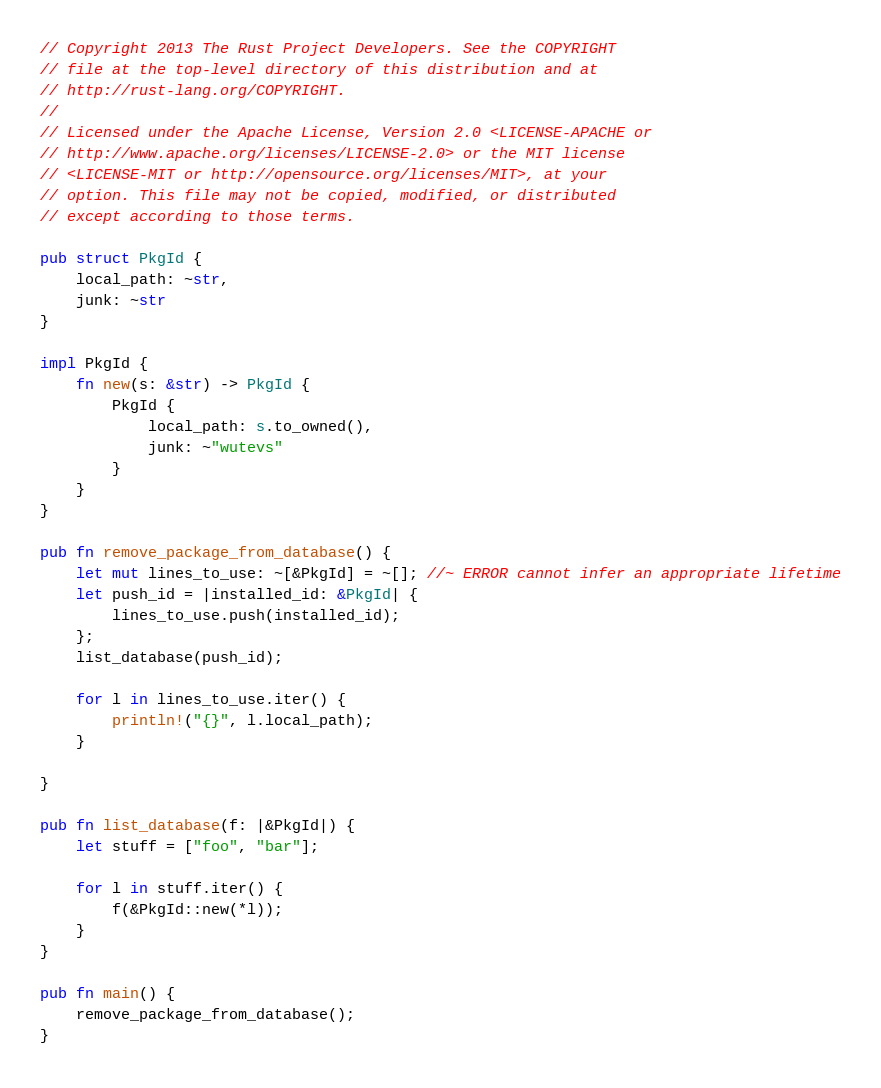<code> <loc_0><loc_0><loc_500><loc_500><_Rust_>// Copyright 2013 The Rust Project Developers. See the COPYRIGHT
// file at the top-level directory of this distribution and at
// http://rust-lang.org/COPYRIGHT.
//
// Licensed under the Apache License, Version 2.0 <LICENSE-APACHE or
// http://www.apache.org/licenses/LICENSE-2.0> or the MIT license
// <LICENSE-MIT or http://opensource.org/licenses/MIT>, at your
// option. This file may not be copied, modified, or distributed
// except according to those terms.

pub struct PkgId {
    local_path: ~str,
    junk: ~str
}

impl PkgId {
    fn new(s: &str) -> PkgId {
        PkgId {
            local_path: s.to_owned(),
            junk: ~"wutevs"
        }
    }
}

pub fn remove_package_from_database() {
    let mut lines_to_use: ~[&PkgId] = ~[]; //~ ERROR cannot infer an appropriate lifetime
    let push_id = |installed_id: &PkgId| {
        lines_to_use.push(installed_id);
    };
    list_database(push_id);

    for l in lines_to_use.iter() {
        println!("{}", l.local_path);
    }

}

pub fn list_database(f: |&PkgId|) {
    let stuff = ["foo", "bar"];

    for l in stuff.iter() {
        f(&PkgId::new(*l));
    }
}

pub fn main() {
    remove_package_from_database();
}
</code> 